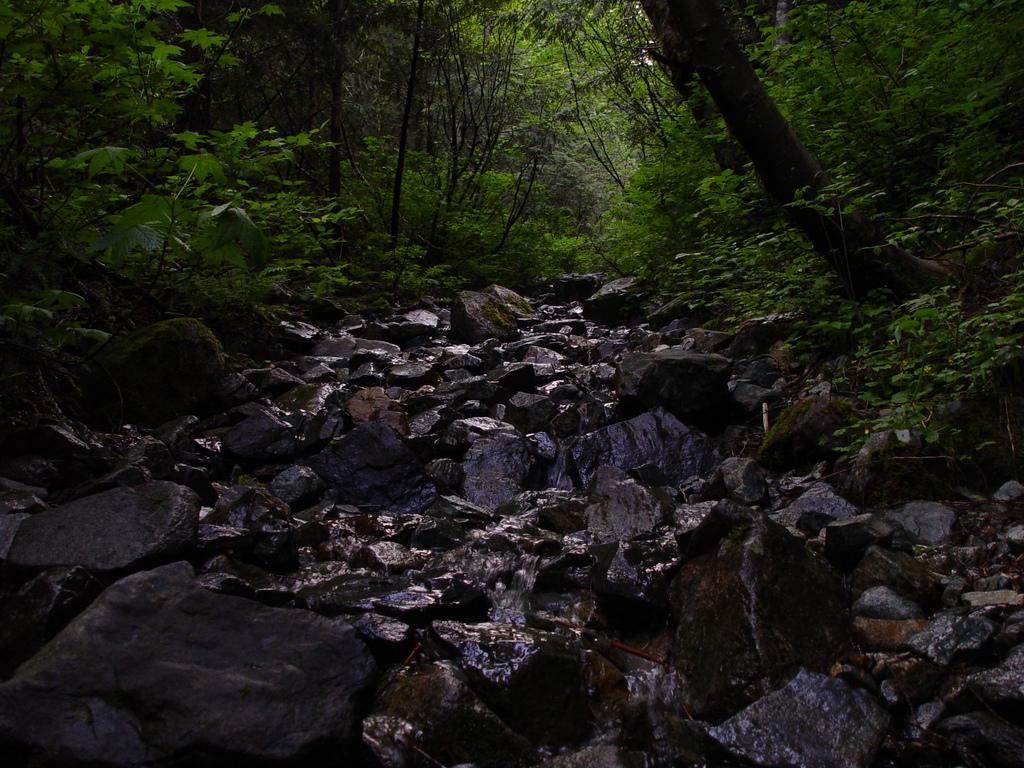What types of vegetation can be seen in the foreground of the image? There are plants and stones in the foreground of the image. What types of vegetation can be seen in the background of the image? There are trees and plants in the background of the image. Can you tell me how many parents are visible in the image? There are no parents present in the image; it features plants, stones, trees, and plants in the foreground and background. What type of mask is being worn by the tree in the background? There are no masks present in the image, as it features plants, stones, trees, and plants in the foreground and background. 